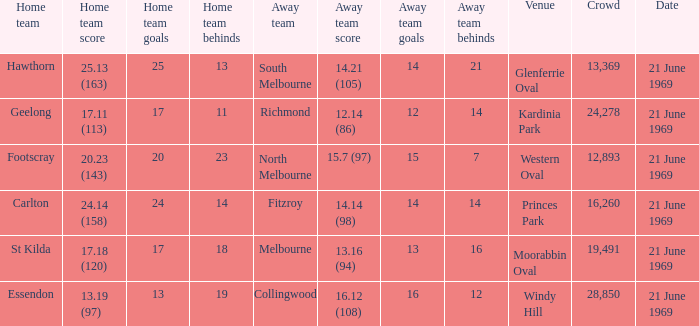When was there a game at Kardinia Park? 21 June 1969. 